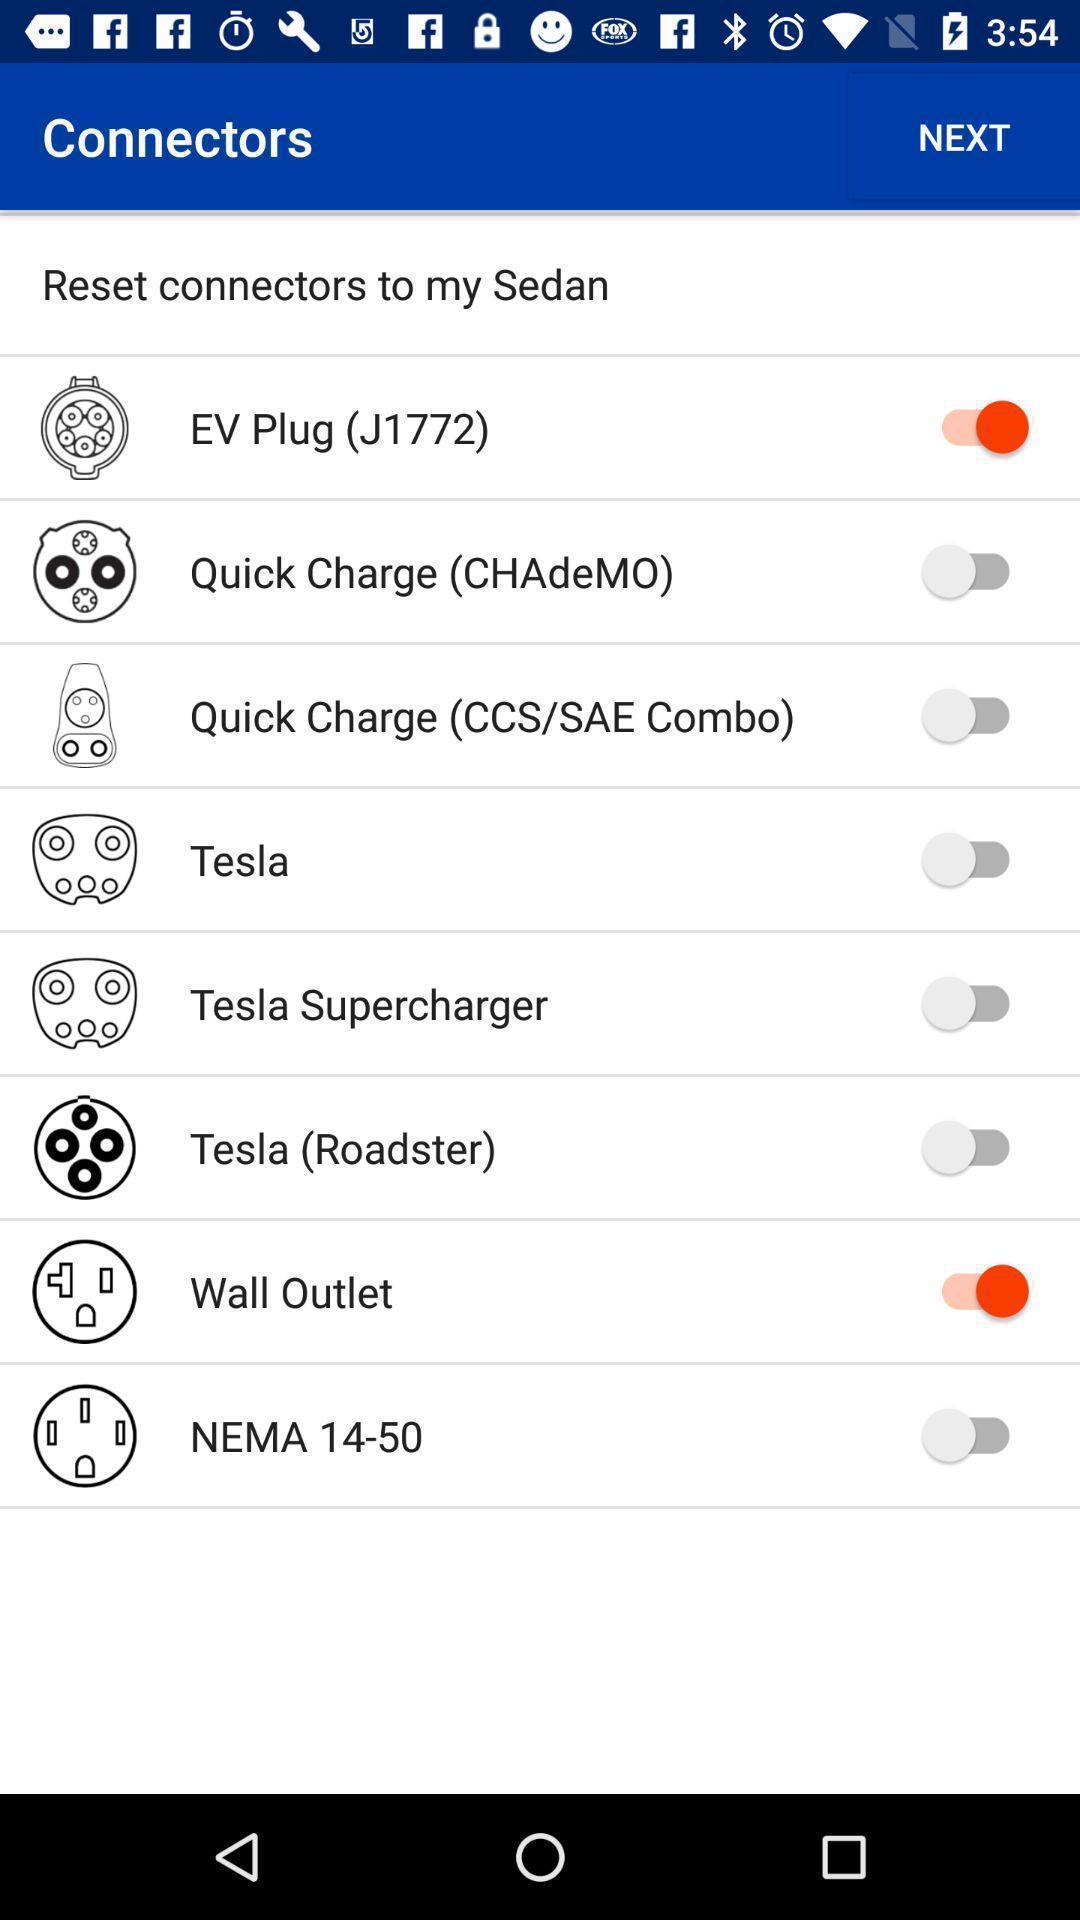Summarize the information in this screenshot. Screen displaying the list of options with toggle icons. 